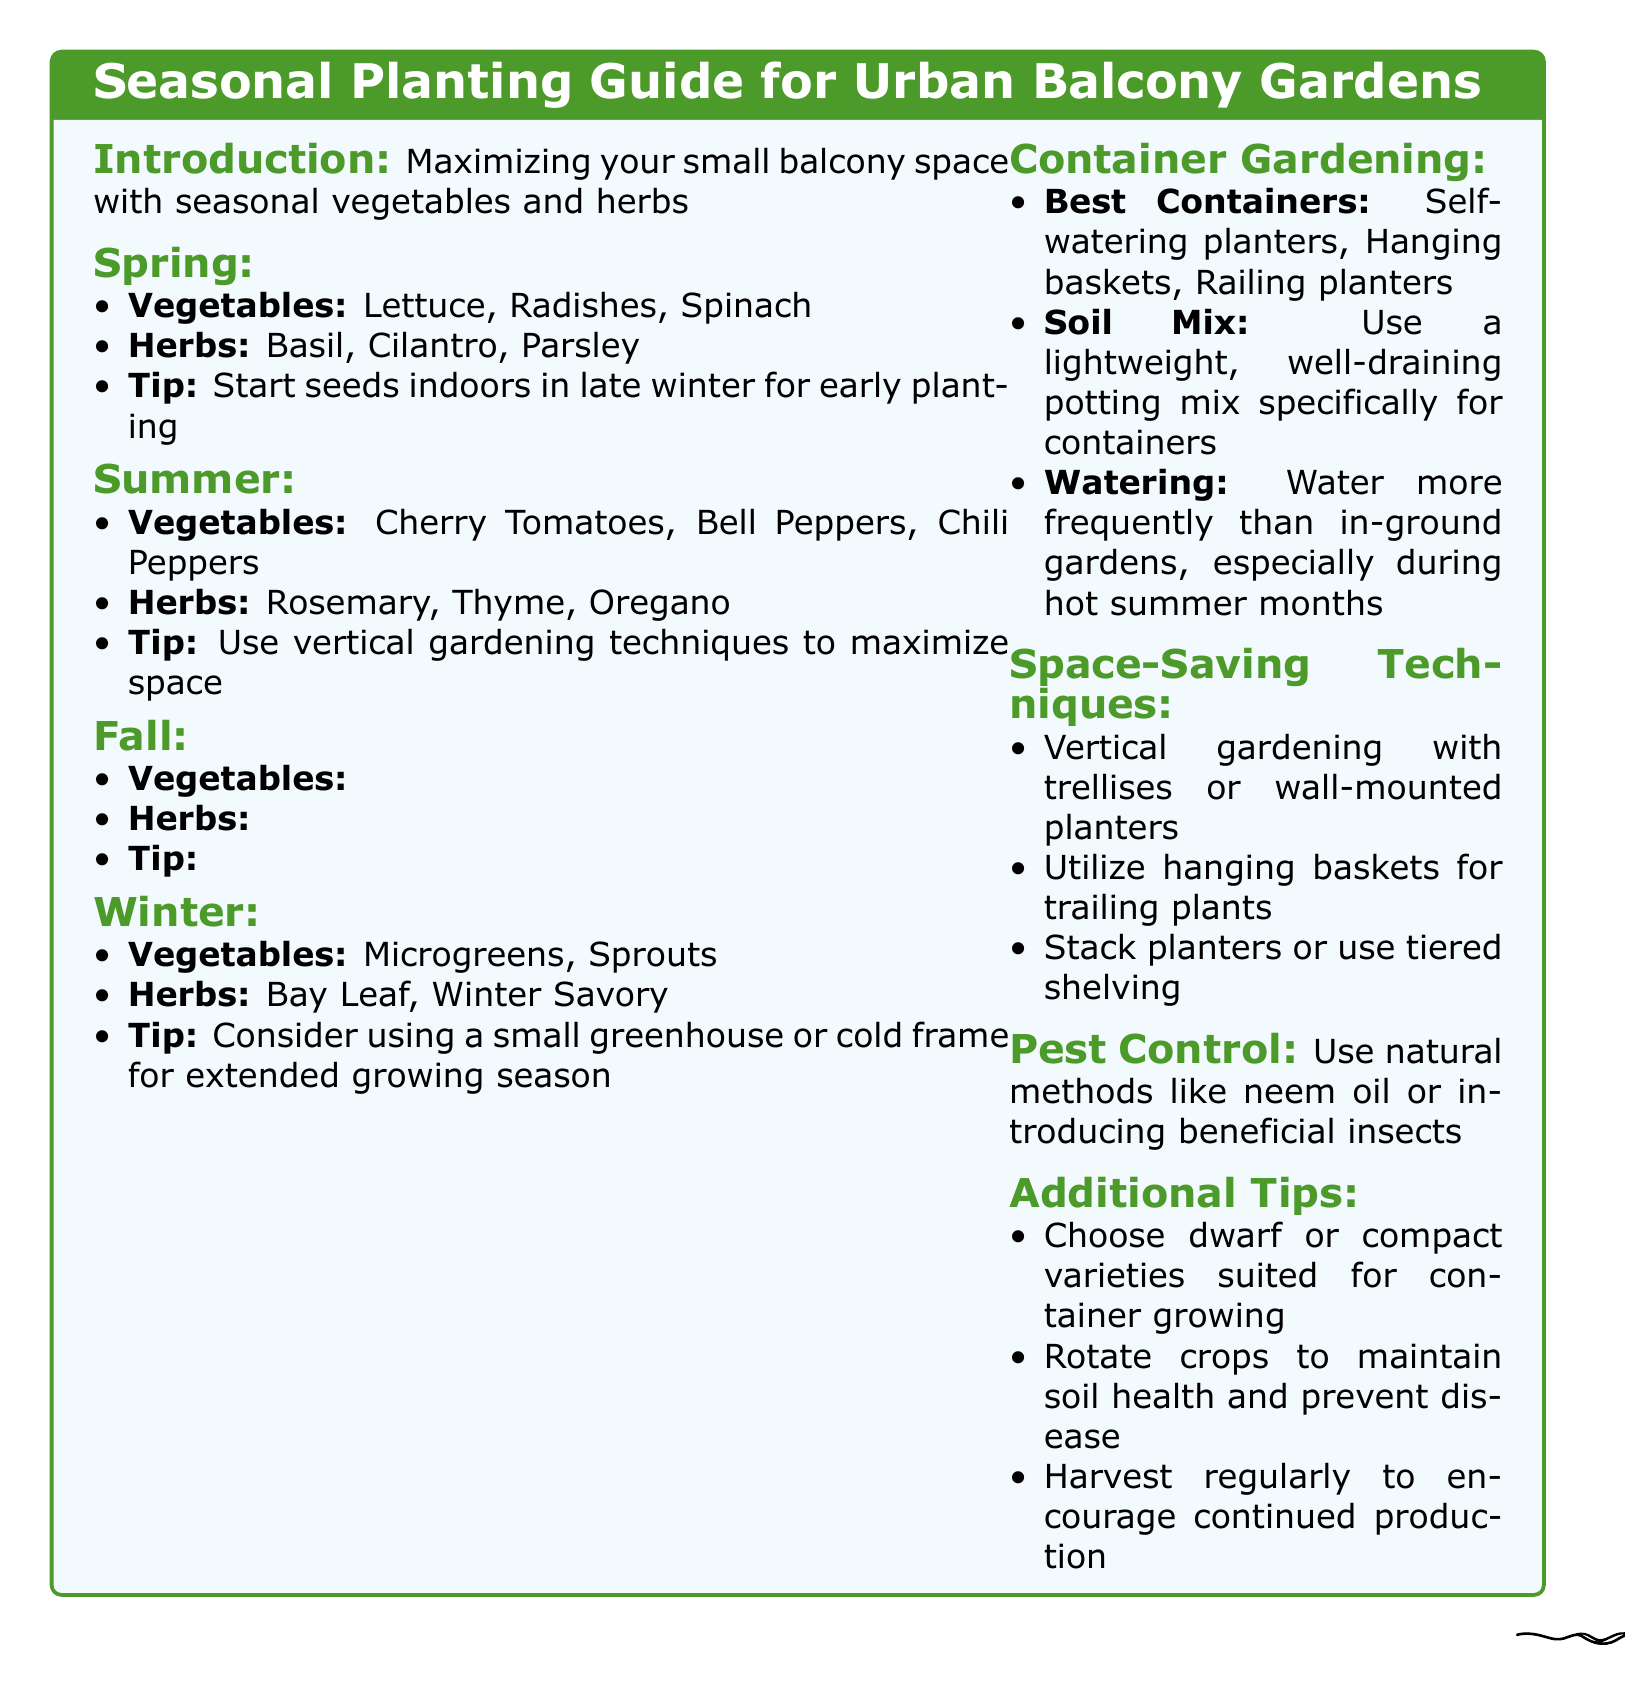What vegetables can be planted in Spring? The document lists the vegetables suitable for Spring planting as Lettuce, Radishes, and Spinach.
Answer: Lettuce, Radishes, Spinach What is a recommended tip for Summer planting? The document advises to use vertical gardening techniques to maximize space during Summer.
Answer: Use vertical gardening techniques to maximize space Name one herb that can be grown in Fall. The document specifies Sage, Chives, and Mint as herbs suitable for Fall planting.
Answer: Sage Which type of container is best for balcony gardening? The document mentions self-watering planters, hanging baskets, and railing planters as the best containers for balcony gardening.
Answer: Self-watering planters What is a space-saving technique mentioned in the document? The document describes vertical gardening with trellises or wall-mounted planters as a space-saving technique.
Answer: Vertical gardening with trellises or wall-mounted planters What is suggested for pest control? According to the document, natural methods like neem oil or introducing beneficial insects are recommended for pest control.
Answer: Use natural methods like neem oil or introducing beneficial insects Which vegetables are suitable for Winter planting? The document states that Microgreens and Sprouts can be planted in Winter.
Answer: Microgreens, Sprouts What is a soil mix recommendation for container gardening? The document suggests using a lightweight, well-draining potting mix specifically for containers.
Answer: Lightweight, well-draining potting mix What should you do to maintain soil health? The document recommends rotating crops to maintain soil health and prevent disease.
Answer: Rotate crops to maintain soil health 